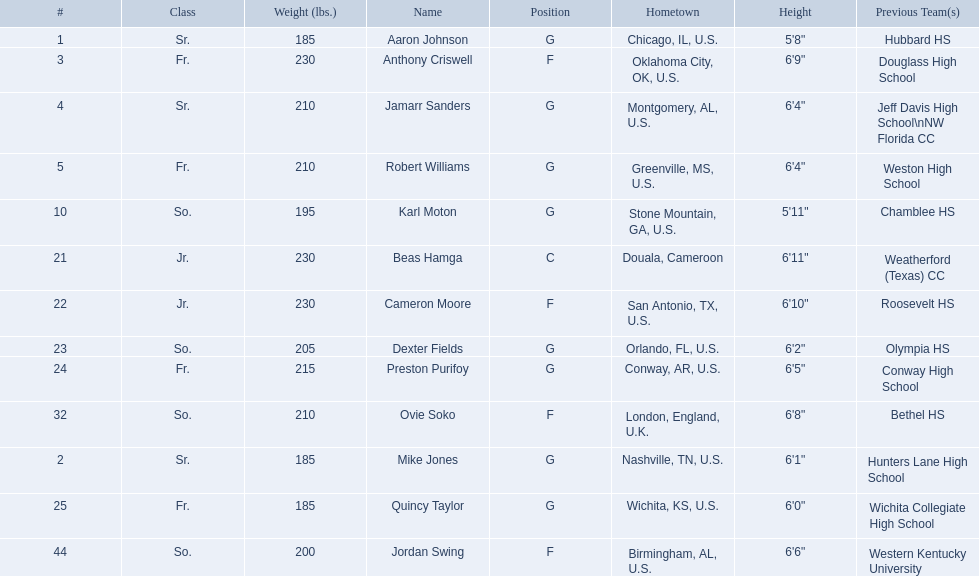Other than soko, who are the players? Aaron Johnson, Anthony Criswell, Jamarr Sanders, Robert Williams, Karl Moton, Beas Hamga, Cameron Moore, Dexter Fields, Preston Purifoy, Mike Jones, Quincy Taylor, Jordan Swing. Of those players, who is a player that is not from the us? Beas Hamga. 